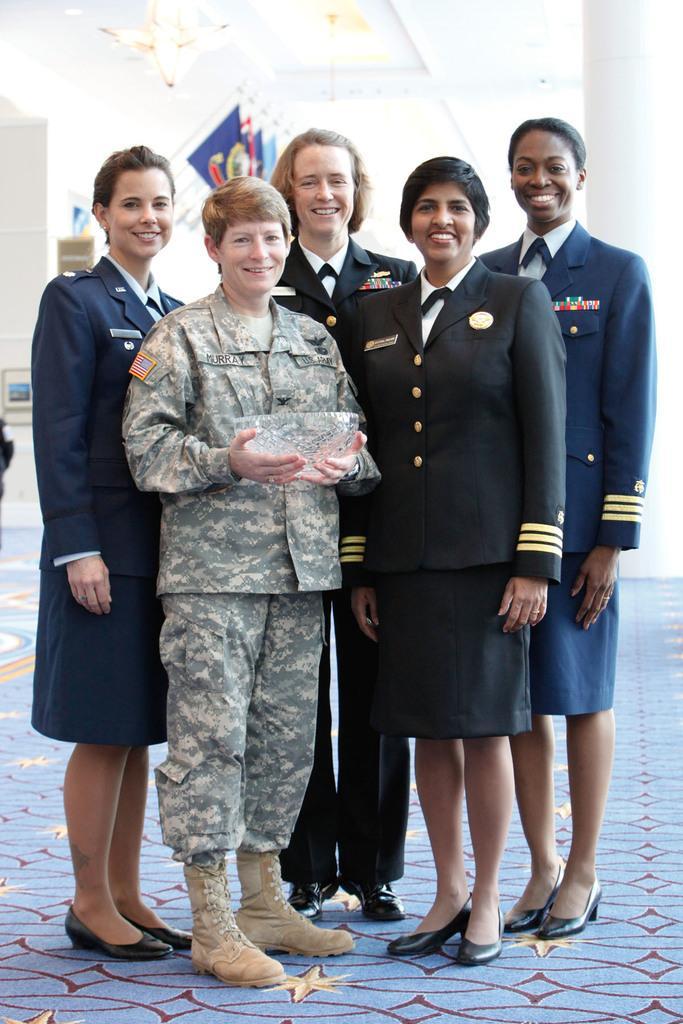Can you describe this image briefly? In this picture we can see group of people, they are smiling, in the middle of the image we can see a woman, she is holding a bowl. 